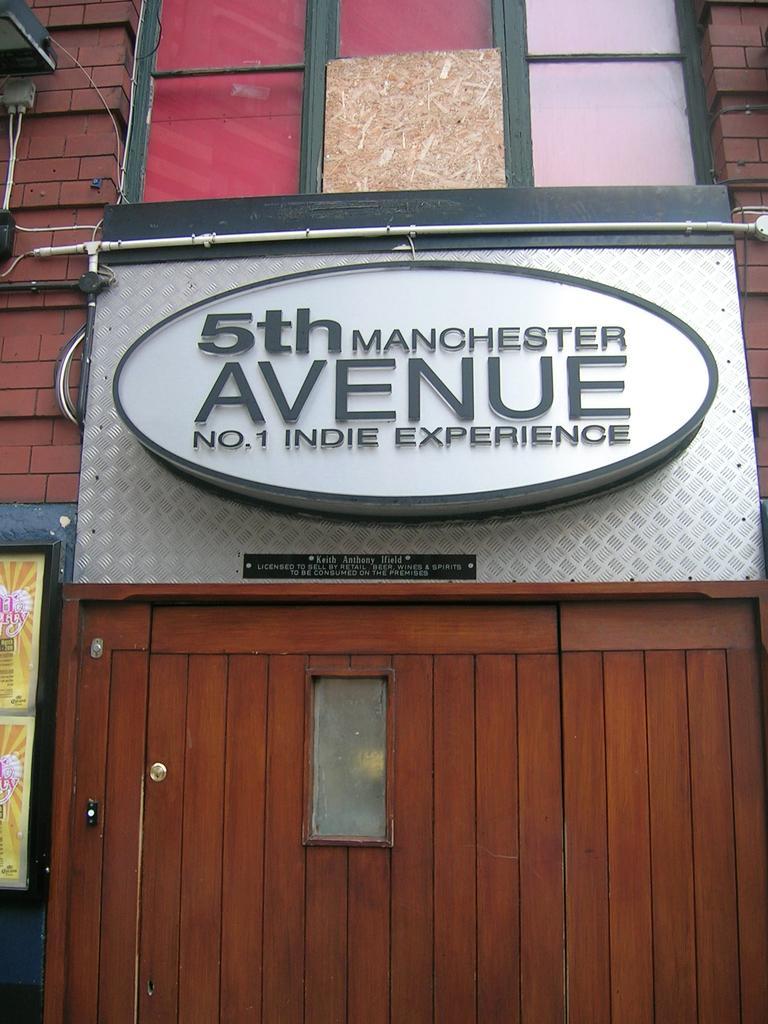In one or two sentences, can you explain what this image depicts? In the image we can see the board and text on it. It looks like the building and the door. 